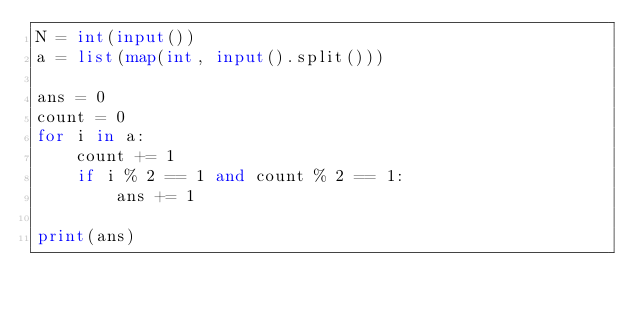<code> <loc_0><loc_0><loc_500><loc_500><_Python_>N = int(input())
a = list(map(int, input().split()))

ans = 0
count = 0
for i in a:
    count += 1
    if i % 2 == 1 and count % 2 == 1:
        ans += 1

print(ans)</code> 